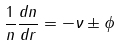<formula> <loc_0><loc_0><loc_500><loc_500>\frac { 1 } { n } \frac { d n } { d r } = - \nu \pm \phi</formula> 